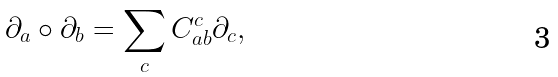<formula> <loc_0><loc_0><loc_500><loc_500>\partial _ { a } \circ \partial _ { b } = \sum _ { c } C _ { a b } ^ { c } \partial _ { c } ,</formula> 